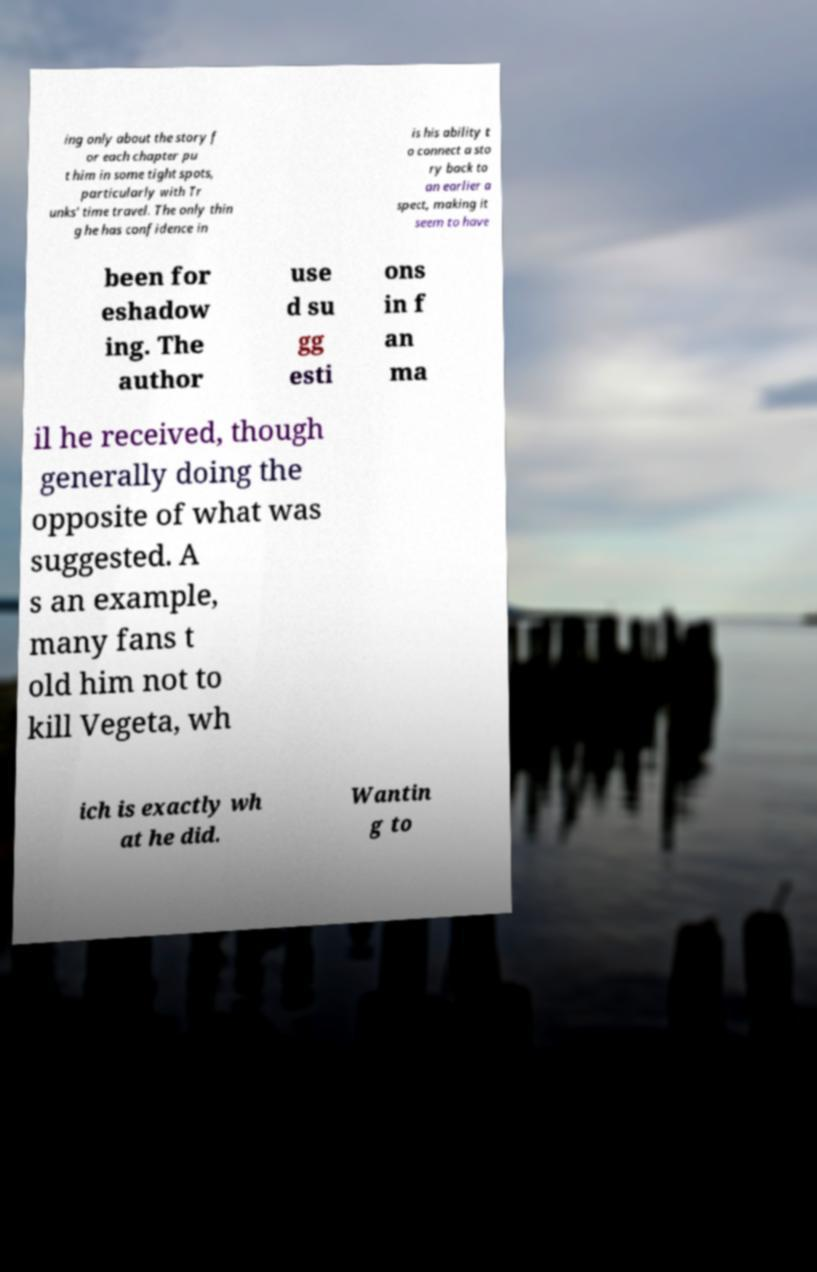For documentation purposes, I need the text within this image transcribed. Could you provide that? ing only about the story f or each chapter pu t him in some tight spots, particularly with Tr unks' time travel. The only thin g he has confidence in is his ability t o connect a sto ry back to an earlier a spect, making it seem to have been for eshadow ing. The author use d su gg esti ons in f an ma il he received, though generally doing the opposite of what was suggested. A s an example, many fans t old him not to kill Vegeta, wh ich is exactly wh at he did. Wantin g to 